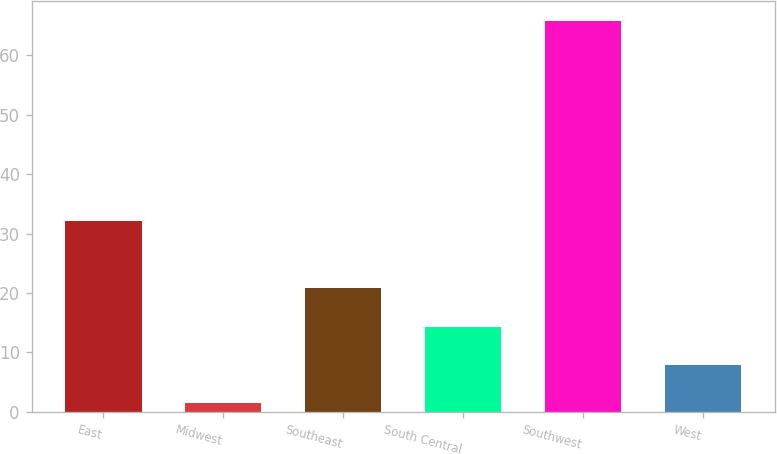Convert chart. <chart><loc_0><loc_0><loc_500><loc_500><bar_chart><fcel>East<fcel>Midwest<fcel>Southeast<fcel>South Central<fcel>Southwest<fcel>West<nl><fcel>32.2<fcel>1.5<fcel>20.79<fcel>14.36<fcel>65.8<fcel>7.93<nl></chart> 